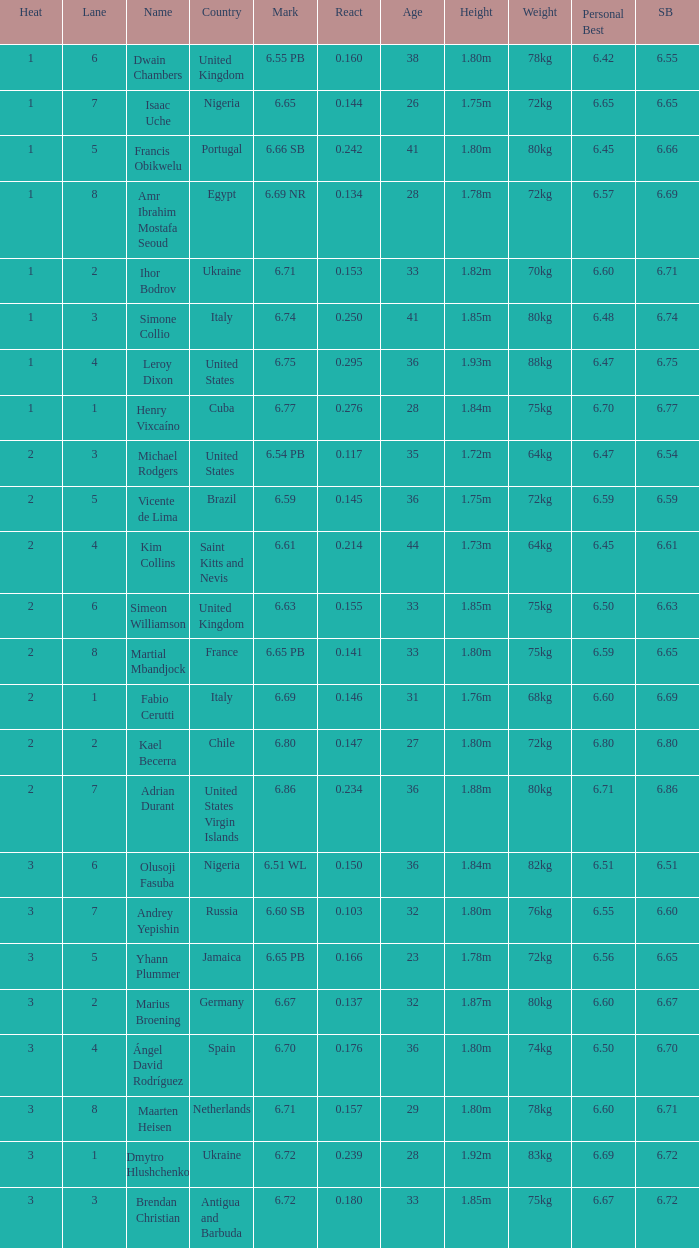What is Country, when Lane is 5, and when React is greater than 0.166? Portugal. 